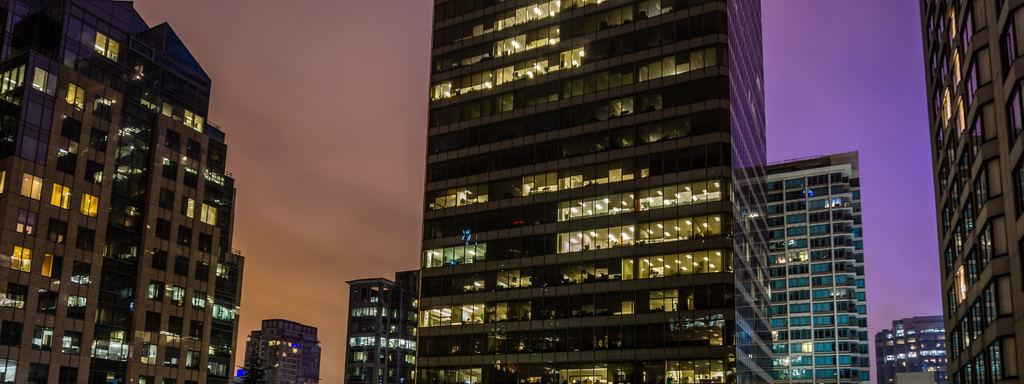What type of structures can be seen in the image? There are buildings in the image. What can be seen illuminating the scene in the image? There are lights visible in the image. What architectural features are present in the buildings? There are windows in the image. What is visible in the background of the image? The sky is visible in the image. What type of ball can be seen rolling down the street in the image? There is no ball present in the image; it only features buildings, lights, windows, and the sky. Can you tell me how many buttons are on the windows in the image? There is no mention of buttons on the windows in the image; only the presence of windows is noted. 